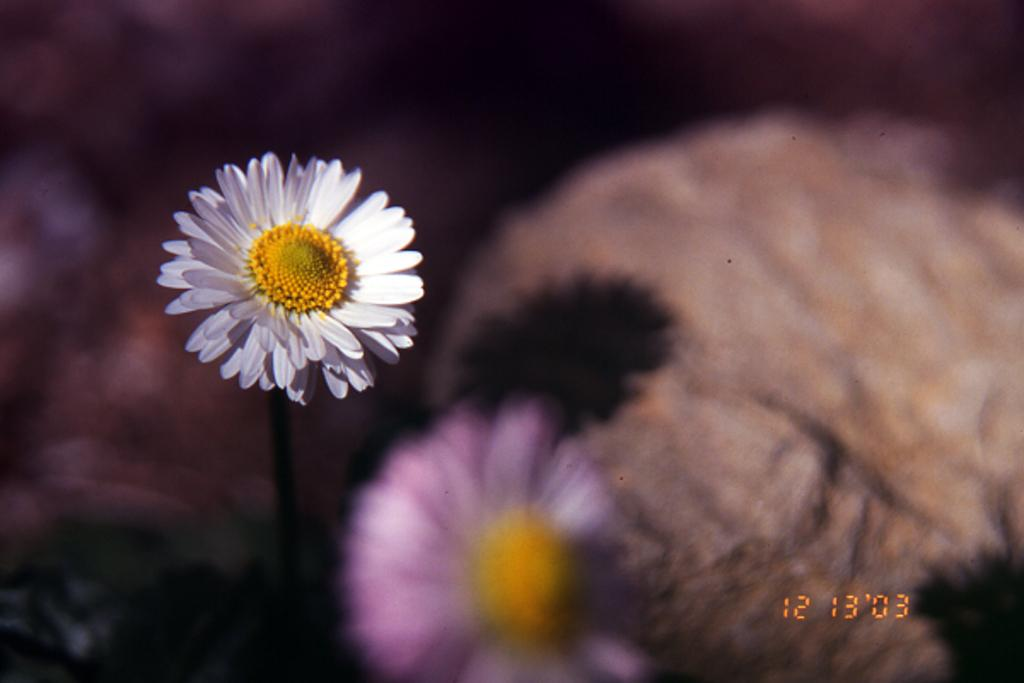What type of living organisms can be seen in the image? There are flowers in the image. Can you describe the background of the image? The background of the image is blurred. Is there any additional information or marking on the image? Yes, there is a watermark on the image. What type of thread is used to create the circle in the image? There is no circle or thread present in the image; it features flowers and a blurred background. 